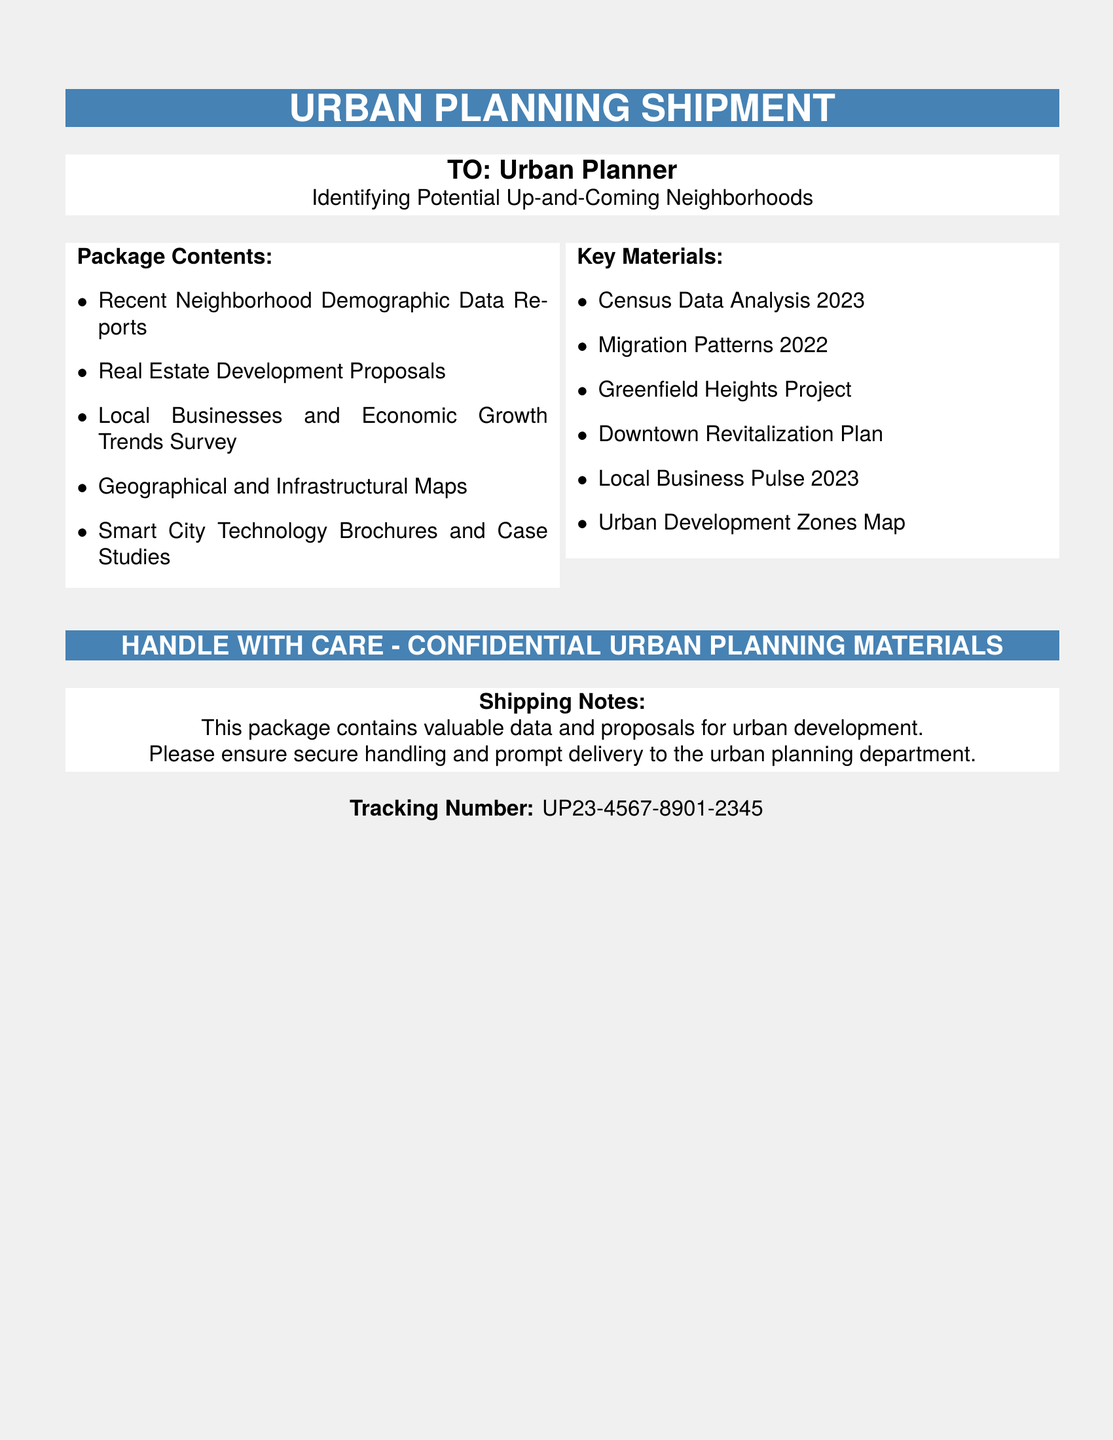What is the tracking number? The tracking number is provided at the bottom of the document as a unique identifier for the shipment.
Answer: UP23-4567-8901-2345 Who is the recipient of the package? The document states the package is addressed to an Urban Planner focused on identifying neighborhoods.
Answer: Urban Planner What is included in the package? The document lists the contents of the package in the 'Package Contents' section, highlighting the various reports and surveys.
Answer: Recent Neighborhood Demographic Data Reports, Real Estate Development Proposals, Local Businesses and Economic Growth Trends Survey, Geographical and Infrastructural Maps, Smart City Technology Brochures and Case Studies What is the significance of the phrase "HANDLE WITH CARE"? This phrase indicates that the materials inside are sensitive and require careful handling due to their importance for urban planning.
Answer: Confidential Urban Planning Materials What type of materials are the key materials classified as? The key materials mentioned in the document are critical for urban planning analysis and development proposals.
Answer: Urban Planning Materials How many items are listed as 'Key Materials'? The document provides a list and counts the number of key materials relevant to the shipment.
Answer: Six items What color is used in the header of the document? The color used in the header of the document is specified to present a professional and cohesive look.
Answer: Urban Blue What year is the most recent census data from? The document mentions census data that plays a crucial role in demographic analysis.
Answer: 2023 What does the shipping note emphasize? The shipping note expresses the importance of the package and the need for secure handling.
Answer: Valuable data and proposals for urban development 